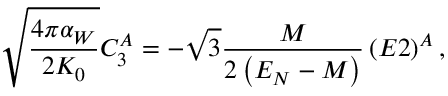Convert formula to latex. <formula><loc_0><loc_0><loc_500><loc_500>\sqrt { \frac { 4 \pi \alpha _ { W } } { 2 K _ { 0 } } } C _ { 3 } ^ { A } = - \sqrt { 3 } \frac { M } 2 \left ( E _ { N } - M \right ) } \left ( E 2 \right ) ^ { A } ,</formula> 